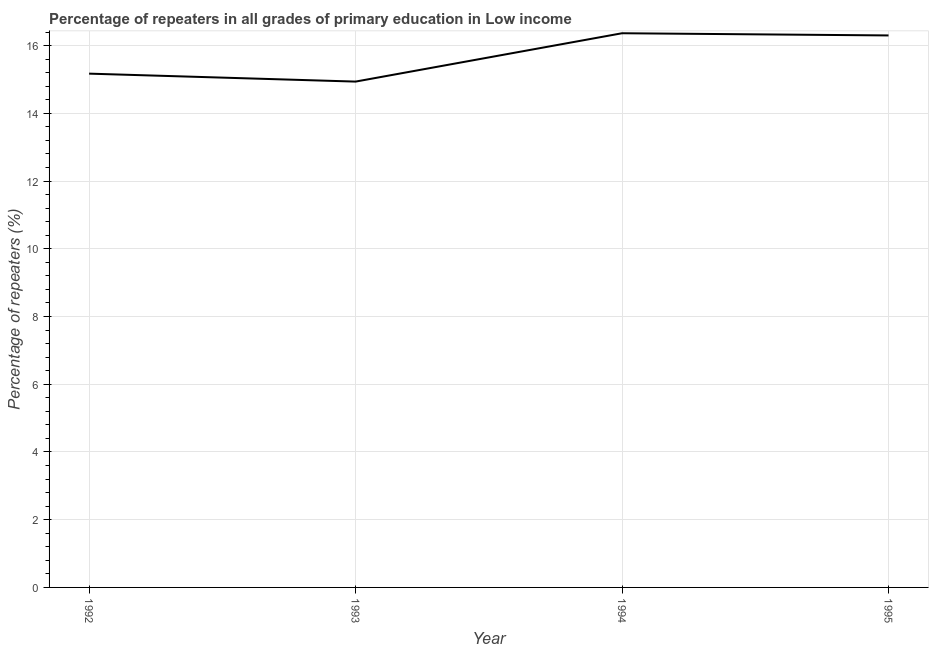What is the percentage of repeaters in primary education in 1993?
Your answer should be very brief. 14.94. Across all years, what is the maximum percentage of repeaters in primary education?
Your answer should be compact. 16.37. Across all years, what is the minimum percentage of repeaters in primary education?
Your response must be concise. 14.94. What is the sum of the percentage of repeaters in primary education?
Give a very brief answer. 62.78. What is the difference between the percentage of repeaters in primary education in 1993 and 1995?
Provide a short and direct response. -1.36. What is the average percentage of repeaters in primary education per year?
Your answer should be compact. 15.69. What is the median percentage of repeaters in primary education?
Keep it short and to the point. 15.74. In how many years, is the percentage of repeaters in primary education greater than 10.4 %?
Provide a succinct answer. 4. Do a majority of the years between 1993 and 1992 (inclusive) have percentage of repeaters in primary education greater than 11.6 %?
Ensure brevity in your answer.  No. What is the ratio of the percentage of repeaters in primary education in 1994 to that in 1995?
Offer a terse response. 1. What is the difference between the highest and the second highest percentage of repeaters in primary education?
Keep it short and to the point. 0.06. Is the sum of the percentage of repeaters in primary education in 1992 and 1993 greater than the maximum percentage of repeaters in primary education across all years?
Provide a short and direct response. Yes. What is the difference between the highest and the lowest percentage of repeaters in primary education?
Make the answer very short. 1.43. How many years are there in the graph?
Your answer should be compact. 4. What is the difference between two consecutive major ticks on the Y-axis?
Make the answer very short. 2. Are the values on the major ticks of Y-axis written in scientific E-notation?
Keep it short and to the point. No. What is the title of the graph?
Your answer should be very brief. Percentage of repeaters in all grades of primary education in Low income. What is the label or title of the X-axis?
Offer a terse response. Year. What is the label or title of the Y-axis?
Keep it short and to the point. Percentage of repeaters (%). What is the Percentage of repeaters (%) of 1992?
Provide a short and direct response. 15.17. What is the Percentage of repeaters (%) of 1993?
Your response must be concise. 14.94. What is the Percentage of repeaters (%) in 1994?
Your response must be concise. 16.37. What is the Percentage of repeaters (%) of 1995?
Make the answer very short. 16.3. What is the difference between the Percentage of repeaters (%) in 1992 and 1993?
Ensure brevity in your answer.  0.23. What is the difference between the Percentage of repeaters (%) in 1992 and 1994?
Offer a terse response. -1.19. What is the difference between the Percentage of repeaters (%) in 1992 and 1995?
Ensure brevity in your answer.  -1.13. What is the difference between the Percentage of repeaters (%) in 1993 and 1994?
Keep it short and to the point. -1.43. What is the difference between the Percentage of repeaters (%) in 1993 and 1995?
Your response must be concise. -1.36. What is the difference between the Percentage of repeaters (%) in 1994 and 1995?
Your response must be concise. 0.06. What is the ratio of the Percentage of repeaters (%) in 1992 to that in 1993?
Make the answer very short. 1.02. What is the ratio of the Percentage of repeaters (%) in 1992 to that in 1994?
Make the answer very short. 0.93. What is the ratio of the Percentage of repeaters (%) in 1992 to that in 1995?
Make the answer very short. 0.93. What is the ratio of the Percentage of repeaters (%) in 1993 to that in 1994?
Your answer should be compact. 0.91. What is the ratio of the Percentage of repeaters (%) in 1993 to that in 1995?
Make the answer very short. 0.92. 